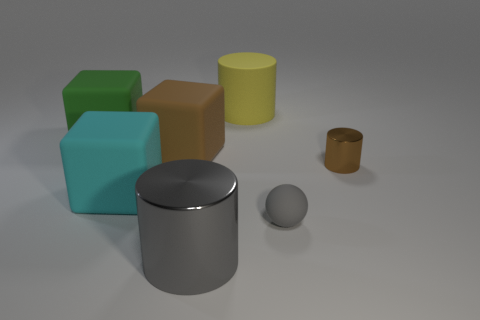How many other objects are the same shape as the large brown matte object?
Keep it short and to the point. 2. Are there fewer cyan matte cubes in front of the cyan cube than cylinders behind the small gray sphere?
Provide a short and direct response. Yes. Do the gray sphere and the big cylinder that is behind the small ball have the same material?
Offer a very short reply. Yes. Are there more tiny cyan shiny cylinders than balls?
Your response must be concise. No. The big rubber thing that is on the right side of the large brown rubber object behind the shiny object on the right side of the matte sphere is what shape?
Ensure brevity in your answer.  Cylinder. Is the block that is to the right of the cyan object made of the same material as the large cylinder behind the tiny gray rubber ball?
Ensure brevity in your answer.  Yes. What shape is the cyan object that is the same material as the big green cube?
Your answer should be very brief. Cube. Are there any other things that are the same color as the sphere?
Make the answer very short. Yes. How many big matte cylinders are there?
Provide a short and direct response. 1. The brown thing to the left of the rubber object that is right of the yellow matte cylinder is made of what material?
Keep it short and to the point. Rubber. 